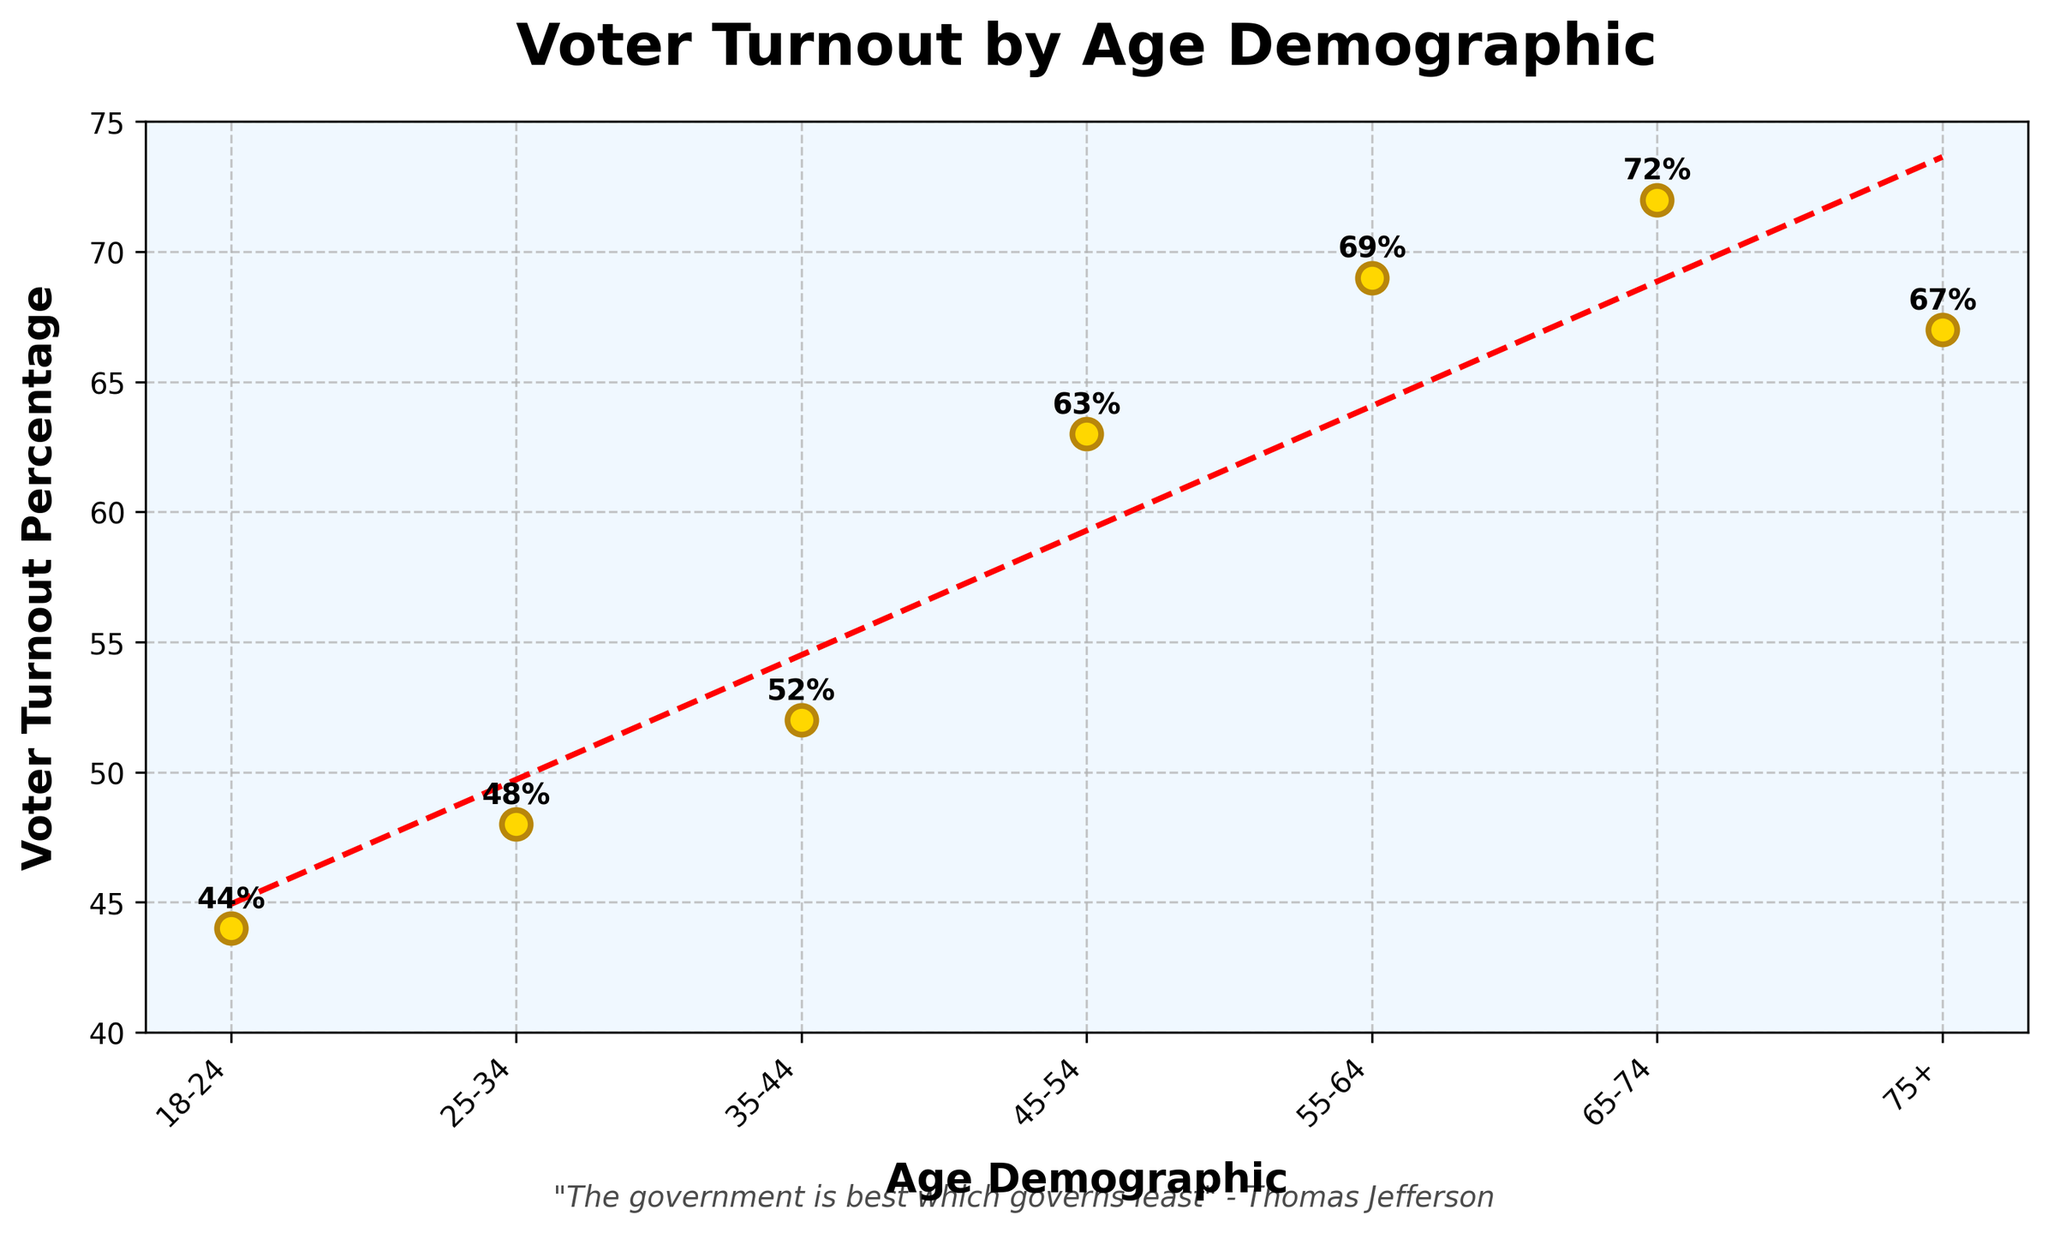what is the trend of voter turnout by age? The trend line in the plot shows an upward slope indicating that voter turnout generally increases with age.
Answer: Upward which age group has the lowest voter turnout percentage? The scatter plot shows that the age demographic '18-24' has the lowest voter turnout percentage, which is annotated as 44% on the plot.
Answer: 18-24 how much higher is voter turnout for the 65-74 age group compared to the 18-24 age group? The voter turnout for the 65-74 age group is 72%, while for the 18-24 age group it is 44%. The difference is calculated as 72% - 44% = 28%.
Answer: 28% what is the average voter turnout percentage across all age demographics? To find the average, sum all the percentages (44 + 48 + 52 + 63 + 69 + 72 + 67) which equals 415, then divide by the number of age groups, 7. The calculation is 415/7 ≈ 59.3%.
Answer: 59.3% is there an age group where the voter turnout exceeds 70%? By looking at the scatter plot with annotated voter turnout percentages, the 65-74 age group has a turnout of 72%, which is the only group exceeding 70%.
Answer: Yes, 65-74 which age group has a voter turnout percentage closest to the overall average turnout? The average voter turnout percentage is approximately 59.3%. The age demographic closest to this average is the 55-64 group, which has a turnout of 69%, the closest to 59.3%.
Answer: 55-64 what is the difference in voter turnout between the 25-34 and 35-44 age groups? The voter turnout for the 25-34 age group is 48%, and for the 35-44 age group, it is 52%. The difference is calculated as 52% - 48% = 4%.
Answer: 4% how does voter turnout change from age 45-54 to age 55-64? The voter turnout increases from 63% in the 45-54 age group to 69% in the 55-64 age group. This represents a 6% increase.
Answer: 6% increase what percentage of voter turnout is represented by the oldest age group (75+)? According to the scatter plot, the turnout percentage for the 75+ age demographic is annotated as 67%.
Answer: 67% 